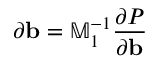Convert formula to latex. <formula><loc_0><loc_0><loc_500><loc_500>\partial b = \mathbb { M } _ { 1 } ^ { - 1 } \frac { \partial P } { \partial { \mathbf b } }</formula> 